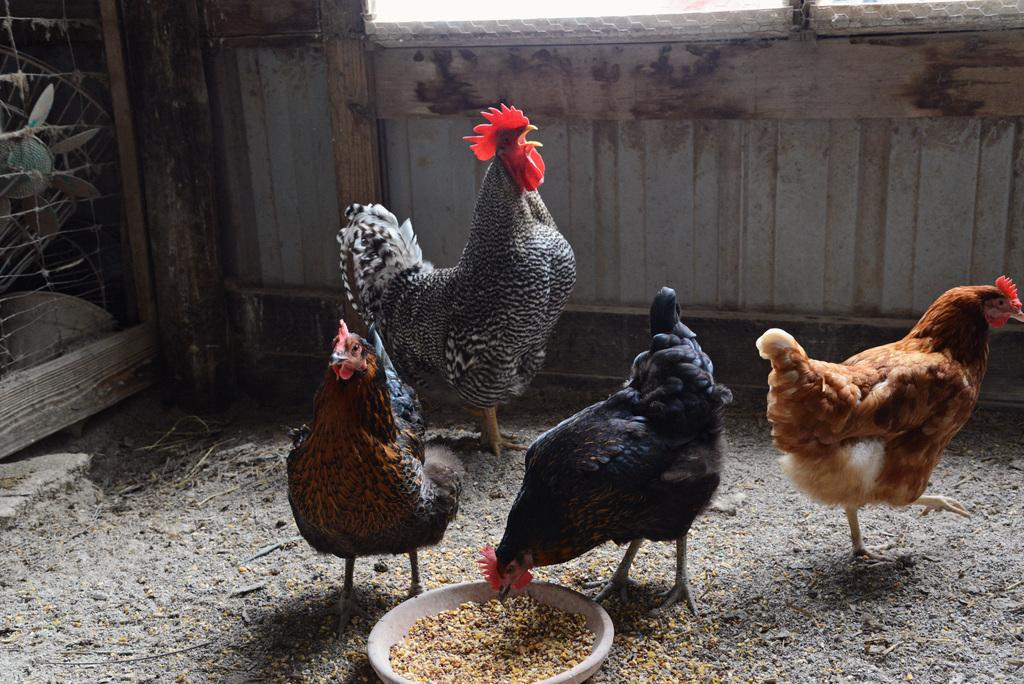What type of animals can be seen on the ground in the image? There are birds on the ground in the image. What is located in the bowl that is visible in the image? There is a bowl with food items in the image. What can be seen in the background of the image? There is a wall with wood in the background of the image, and a few objects are also visible. What time of day is it in the image, specifically in the afternoon? The time of day is not mentioned in the image, so it cannot be determined if it is specifically in the afternoon. What type of drum can be seen in the image? There is no drum present in the image. 